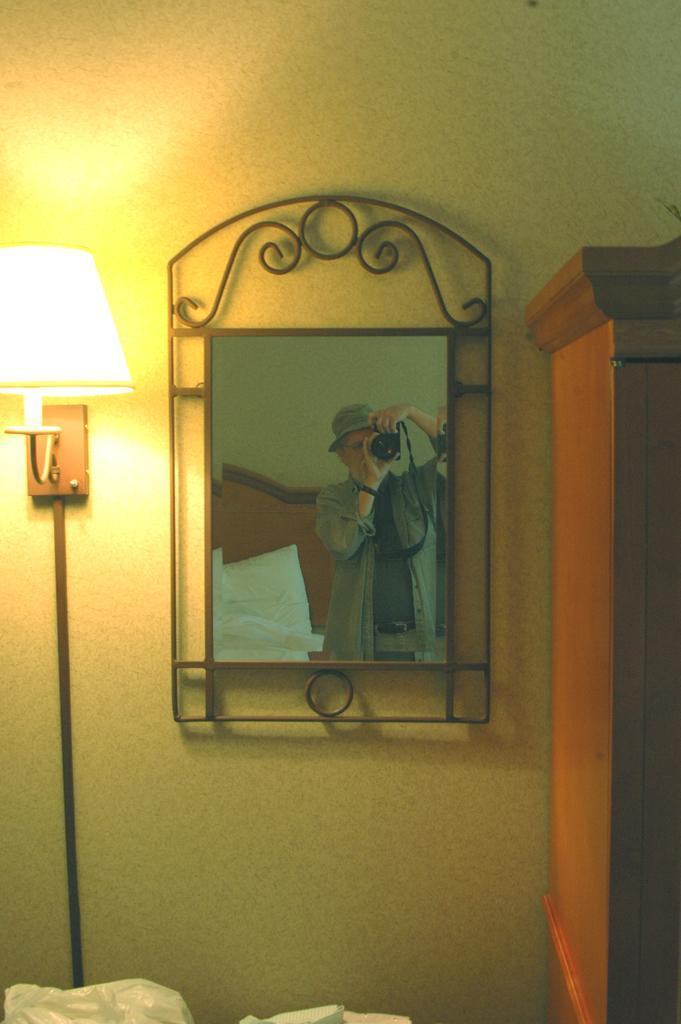What is the main object in the center of the image? There is a photo frame in the center of the image. What type of furniture is on the right side of the image? There is a cabinet on the right side of the image. What is the object on the left side of the image? There is a lamp on the left side of the image. What type of paper is visible in the stomach of the lamp in the image? There is no paper or stomach present in the lamp in the image; it is an object with a base, a stand, and a light source. 